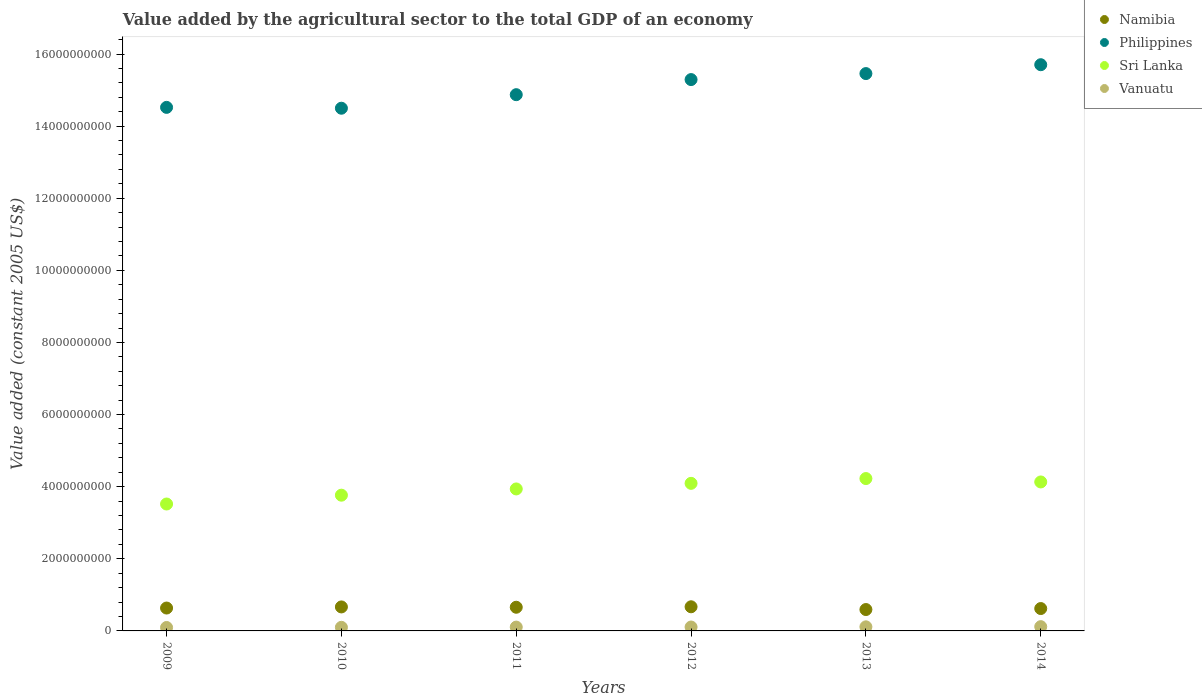How many different coloured dotlines are there?
Provide a succinct answer. 4. Is the number of dotlines equal to the number of legend labels?
Give a very brief answer. Yes. What is the value added by the agricultural sector in Philippines in 2009?
Offer a very short reply. 1.45e+1. Across all years, what is the maximum value added by the agricultural sector in Sri Lanka?
Your answer should be very brief. 4.23e+09. Across all years, what is the minimum value added by the agricultural sector in Philippines?
Make the answer very short. 1.45e+1. In which year was the value added by the agricultural sector in Sri Lanka maximum?
Provide a succinct answer. 2013. What is the total value added by the agricultural sector in Namibia in the graph?
Your answer should be compact. 3.84e+09. What is the difference between the value added by the agricultural sector in Philippines in 2012 and that in 2013?
Offer a terse response. -1.66e+08. What is the difference between the value added by the agricultural sector in Vanuatu in 2014 and the value added by the agricultural sector in Philippines in 2010?
Your answer should be very brief. -1.44e+1. What is the average value added by the agricultural sector in Sri Lanka per year?
Your response must be concise. 3.95e+09. In the year 2012, what is the difference between the value added by the agricultural sector in Namibia and value added by the agricultural sector in Sri Lanka?
Your response must be concise. -3.42e+09. In how many years, is the value added by the agricultural sector in Sri Lanka greater than 9200000000 US$?
Make the answer very short. 0. What is the ratio of the value added by the agricultural sector in Vanuatu in 2009 to that in 2010?
Give a very brief answer. 0.95. What is the difference between the highest and the second highest value added by the agricultural sector in Sri Lanka?
Provide a succinct answer. 9.42e+07. What is the difference between the highest and the lowest value added by the agricultural sector in Namibia?
Your answer should be compact. 7.63e+07. Is it the case that in every year, the sum of the value added by the agricultural sector in Vanuatu and value added by the agricultural sector in Namibia  is greater than the value added by the agricultural sector in Sri Lanka?
Provide a short and direct response. No. Is the value added by the agricultural sector in Namibia strictly less than the value added by the agricultural sector in Sri Lanka over the years?
Provide a short and direct response. Yes. Are the values on the major ticks of Y-axis written in scientific E-notation?
Provide a short and direct response. No. Does the graph contain any zero values?
Offer a very short reply. No. Where does the legend appear in the graph?
Keep it short and to the point. Top right. How many legend labels are there?
Provide a succinct answer. 4. What is the title of the graph?
Your answer should be compact. Value added by the agricultural sector to the total GDP of an economy. Does "Congo (Democratic)" appear as one of the legend labels in the graph?
Ensure brevity in your answer.  No. What is the label or title of the X-axis?
Your answer should be very brief. Years. What is the label or title of the Y-axis?
Provide a short and direct response. Value added (constant 2005 US$). What is the Value added (constant 2005 US$) of Namibia in 2009?
Provide a short and direct response. 6.35e+08. What is the Value added (constant 2005 US$) of Philippines in 2009?
Provide a succinct answer. 1.45e+1. What is the Value added (constant 2005 US$) of Sri Lanka in 2009?
Offer a terse response. 3.52e+09. What is the Value added (constant 2005 US$) of Vanuatu in 2009?
Your response must be concise. 9.54e+07. What is the Value added (constant 2005 US$) in Namibia in 2010?
Keep it short and to the point. 6.65e+08. What is the Value added (constant 2005 US$) of Philippines in 2010?
Keep it short and to the point. 1.45e+1. What is the Value added (constant 2005 US$) in Sri Lanka in 2010?
Give a very brief answer. 3.76e+09. What is the Value added (constant 2005 US$) in Vanuatu in 2010?
Your answer should be very brief. 1.00e+08. What is the Value added (constant 2005 US$) of Namibia in 2011?
Give a very brief answer. 6.57e+08. What is the Value added (constant 2005 US$) in Philippines in 2011?
Your response must be concise. 1.49e+1. What is the Value added (constant 2005 US$) of Sri Lanka in 2011?
Your answer should be very brief. 3.94e+09. What is the Value added (constant 2005 US$) in Vanuatu in 2011?
Your response must be concise. 1.06e+08. What is the Value added (constant 2005 US$) of Namibia in 2012?
Your response must be concise. 6.69e+08. What is the Value added (constant 2005 US$) of Philippines in 2012?
Provide a succinct answer. 1.53e+1. What is the Value added (constant 2005 US$) in Sri Lanka in 2012?
Offer a terse response. 4.09e+09. What is the Value added (constant 2005 US$) of Vanuatu in 2012?
Your answer should be very brief. 1.08e+08. What is the Value added (constant 2005 US$) of Namibia in 2013?
Give a very brief answer. 5.93e+08. What is the Value added (constant 2005 US$) of Philippines in 2013?
Your response must be concise. 1.55e+1. What is the Value added (constant 2005 US$) of Sri Lanka in 2013?
Keep it short and to the point. 4.23e+09. What is the Value added (constant 2005 US$) of Vanuatu in 2013?
Your response must be concise. 1.14e+08. What is the Value added (constant 2005 US$) of Namibia in 2014?
Ensure brevity in your answer.  6.21e+08. What is the Value added (constant 2005 US$) in Philippines in 2014?
Your response must be concise. 1.57e+1. What is the Value added (constant 2005 US$) of Sri Lanka in 2014?
Ensure brevity in your answer.  4.13e+09. What is the Value added (constant 2005 US$) of Vanuatu in 2014?
Your answer should be very brief. 1.18e+08. Across all years, what is the maximum Value added (constant 2005 US$) of Namibia?
Your answer should be very brief. 6.69e+08. Across all years, what is the maximum Value added (constant 2005 US$) in Philippines?
Your response must be concise. 1.57e+1. Across all years, what is the maximum Value added (constant 2005 US$) in Sri Lanka?
Offer a terse response. 4.23e+09. Across all years, what is the maximum Value added (constant 2005 US$) in Vanuatu?
Offer a very short reply. 1.18e+08. Across all years, what is the minimum Value added (constant 2005 US$) in Namibia?
Provide a short and direct response. 5.93e+08. Across all years, what is the minimum Value added (constant 2005 US$) in Philippines?
Your answer should be very brief. 1.45e+1. Across all years, what is the minimum Value added (constant 2005 US$) in Sri Lanka?
Provide a succinct answer. 3.52e+09. Across all years, what is the minimum Value added (constant 2005 US$) in Vanuatu?
Offer a very short reply. 9.54e+07. What is the total Value added (constant 2005 US$) in Namibia in the graph?
Offer a terse response. 3.84e+09. What is the total Value added (constant 2005 US$) in Philippines in the graph?
Offer a terse response. 9.03e+1. What is the total Value added (constant 2005 US$) of Sri Lanka in the graph?
Your answer should be very brief. 2.37e+1. What is the total Value added (constant 2005 US$) in Vanuatu in the graph?
Your answer should be very brief. 6.42e+08. What is the difference between the Value added (constant 2005 US$) of Namibia in 2009 and that in 2010?
Your answer should be compact. -3.08e+07. What is the difference between the Value added (constant 2005 US$) of Philippines in 2009 and that in 2010?
Ensure brevity in your answer.  2.36e+07. What is the difference between the Value added (constant 2005 US$) in Sri Lanka in 2009 and that in 2010?
Provide a short and direct response. -2.45e+08. What is the difference between the Value added (constant 2005 US$) in Vanuatu in 2009 and that in 2010?
Provide a succinct answer. -4.59e+06. What is the difference between the Value added (constant 2005 US$) of Namibia in 2009 and that in 2011?
Offer a very short reply. -2.20e+07. What is the difference between the Value added (constant 2005 US$) in Philippines in 2009 and that in 2011?
Provide a succinct answer. -3.52e+08. What is the difference between the Value added (constant 2005 US$) in Sri Lanka in 2009 and that in 2011?
Offer a terse response. -4.18e+08. What is the difference between the Value added (constant 2005 US$) of Vanuatu in 2009 and that in 2011?
Provide a succinct answer. -1.07e+07. What is the difference between the Value added (constant 2005 US$) of Namibia in 2009 and that in 2012?
Give a very brief answer. -3.49e+07. What is the difference between the Value added (constant 2005 US$) of Philippines in 2009 and that in 2012?
Your answer should be very brief. -7.71e+08. What is the difference between the Value added (constant 2005 US$) in Sri Lanka in 2009 and that in 2012?
Your response must be concise. -5.73e+08. What is the difference between the Value added (constant 2005 US$) in Vanuatu in 2009 and that in 2012?
Your answer should be compact. -1.30e+07. What is the difference between the Value added (constant 2005 US$) of Namibia in 2009 and that in 2013?
Your response must be concise. 4.15e+07. What is the difference between the Value added (constant 2005 US$) of Philippines in 2009 and that in 2013?
Your response must be concise. -9.37e+08. What is the difference between the Value added (constant 2005 US$) of Sri Lanka in 2009 and that in 2013?
Offer a terse response. -7.06e+08. What is the difference between the Value added (constant 2005 US$) in Vanuatu in 2009 and that in 2013?
Give a very brief answer. -1.82e+07. What is the difference between the Value added (constant 2005 US$) in Namibia in 2009 and that in 2014?
Your answer should be compact. 1.40e+07. What is the difference between the Value added (constant 2005 US$) in Philippines in 2009 and that in 2014?
Provide a succinct answer. -1.18e+09. What is the difference between the Value added (constant 2005 US$) of Sri Lanka in 2009 and that in 2014?
Make the answer very short. -6.12e+08. What is the difference between the Value added (constant 2005 US$) in Vanuatu in 2009 and that in 2014?
Offer a very short reply. -2.30e+07. What is the difference between the Value added (constant 2005 US$) in Namibia in 2010 and that in 2011?
Your answer should be very brief. 8.85e+06. What is the difference between the Value added (constant 2005 US$) of Philippines in 2010 and that in 2011?
Provide a succinct answer. -3.76e+08. What is the difference between the Value added (constant 2005 US$) in Sri Lanka in 2010 and that in 2011?
Offer a terse response. -1.73e+08. What is the difference between the Value added (constant 2005 US$) of Vanuatu in 2010 and that in 2011?
Provide a succinct answer. -6.06e+06. What is the difference between the Value added (constant 2005 US$) in Namibia in 2010 and that in 2012?
Provide a short and direct response. -4.06e+06. What is the difference between the Value added (constant 2005 US$) in Philippines in 2010 and that in 2012?
Your answer should be very brief. -7.94e+08. What is the difference between the Value added (constant 2005 US$) in Sri Lanka in 2010 and that in 2012?
Your response must be concise. -3.28e+08. What is the difference between the Value added (constant 2005 US$) in Vanuatu in 2010 and that in 2012?
Ensure brevity in your answer.  -8.42e+06. What is the difference between the Value added (constant 2005 US$) in Namibia in 2010 and that in 2013?
Provide a succinct answer. 7.23e+07. What is the difference between the Value added (constant 2005 US$) in Philippines in 2010 and that in 2013?
Your answer should be very brief. -9.61e+08. What is the difference between the Value added (constant 2005 US$) in Sri Lanka in 2010 and that in 2013?
Your answer should be compact. -4.61e+08. What is the difference between the Value added (constant 2005 US$) in Vanuatu in 2010 and that in 2013?
Offer a terse response. -1.36e+07. What is the difference between the Value added (constant 2005 US$) of Namibia in 2010 and that in 2014?
Ensure brevity in your answer.  4.48e+07. What is the difference between the Value added (constant 2005 US$) of Philippines in 2010 and that in 2014?
Offer a very short reply. -1.21e+09. What is the difference between the Value added (constant 2005 US$) in Sri Lanka in 2010 and that in 2014?
Provide a short and direct response. -3.67e+08. What is the difference between the Value added (constant 2005 US$) of Vanuatu in 2010 and that in 2014?
Make the answer very short. -1.84e+07. What is the difference between the Value added (constant 2005 US$) in Namibia in 2011 and that in 2012?
Make the answer very short. -1.29e+07. What is the difference between the Value added (constant 2005 US$) of Philippines in 2011 and that in 2012?
Your response must be concise. -4.19e+08. What is the difference between the Value added (constant 2005 US$) in Sri Lanka in 2011 and that in 2012?
Give a very brief answer. -1.55e+08. What is the difference between the Value added (constant 2005 US$) of Vanuatu in 2011 and that in 2012?
Give a very brief answer. -2.35e+06. What is the difference between the Value added (constant 2005 US$) of Namibia in 2011 and that in 2013?
Your answer should be compact. 6.34e+07. What is the difference between the Value added (constant 2005 US$) of Philippines in 2011 and that in 2013?
Provide a succinct answer. -5.85e+08. What is the difference between the Value added (constant 2005 US$) in Sri Lanka in 2011 and that in 2013?
Ensure brevity in your answer.  -2.88e+08. What is the difference between the Value added (constant 2005 US$) of Vanuatu in 2011 and that in 2013?
Provide a short and direct response. -7.53e+06. What is the difference between the Value added (constant 2005 US$) in Namibia in 2011 and that in 2014?
Provide a succinct answer. 3.60e+07. What is the difference between the Value added (constant 2005 US$) in Philippines in 2011 and that in 2014?
Offer a terse response. -8.31e+08. What is the difference between the Value added (constant 2005 US$) of Sri Lanka in 2011 and that in 2014?
Make the answer very short. -1.94e+08. What is the difference between the Value added (constant 2005 US$) in Vanuatu in 2011 and that in 2014?
Ensure brevity in your answer.  -1.23e+07. What is the difference between the Value added (constant 2005 US$) of Namibia in 2012 and that in 2013?
Your answer should be compact. 7.63e+07. What is the difference between the Value added (constant 2005 US$) in Philippines in 2012 and that in 2013?
Make the answer very short. -1.66e+08. What is the difference between the Value added (constant 2005 US$) in Sri Lanka in 2012 and that in 2013?
Make the answer very short. -1.33e+08. What is the difference between the Value added (constant 2005 US$) in Vanuatu in 2012 and that in 2013?
Your response must be concise. -5.18e+06. What is the difference between the Value added (constant 2005 US$) in Namibia in 2012 and that in 2014?
Make the answer very short. 4.89e+07. What is the difference between the Value added (constant 2005 US$) in Philippines in 2012 and that in 2014?
Offer a terse response. -4.12e+08. What is the difference between the Value added (constant 2005 US$) in Sri Lanka in 2012 and that in 2014?
Give a very brief answer. -3.87e+07. What is the difference between the Value added (constant 2005 US$) in Vanuatu in 2012 and that in 2014?
Provide a succinct answer. -9.97e+06. What is the difference between the Value added (constant 2005 US$) in Namibia in 2013 and that in 2014?
Offer a terse response. -2.74e+07. What is the difference between the Value added (constant 2005 US$) of Philippines in 2013 and that in 2014?
Provide a succinct answer. -2.46e+08. What is the difference between the Value added (constant 2005 US$) in Sri Lanka in 2013 and that in 2014?
Make the answer very short. 9.42e+07. What is the difference between the Value added (constant 2005 US$) in Vanuatu in 2013 and that in 2014?
Offer a terse response. -4.79e+06. What is the difference between the Value added (constant 2005 US$) in Namibia in 2009 and the Value added (constant 2005 US$) in Philippines in 2010?
Your answer should be very brief. -1.39e+1. What is the difference between the Value added (constant 2005 US$) of Namibia in 2009 and the Value added (constant 2005 US$) of Sri Lanka in 2010?
Keep it short and to the point. -3.13e+09. What is the difference between the Value added (constant 2005 US$) in Namibia in 2009 and the Value added (constant 2005 US$) in Vanuatu in 2010?
Offer a terse response. 5.35e+08. What is the difference between the Value added (constant 2005 US$) of Philippines in 2009 and the Value added (constant 2005 US$) of Sri Lanka in 2010?
Your response must be concise. 1.08e+1. What is the difference between the Value added (constant 2005 US$) of Philippines in 2009 and the Value added (constant 2005 US$) of Vanuatu in 2010?
Provide a succinct answer. 1.44e+1. What is the difference between the Value added (constant 2005 US$) in Sri Lanka in 2009 and the Value added (constant 2005 US$) in Vanuatu in 2010?
Give a very brief answer. 3.42e+09. What is the difference between the Value added (constant 2005 US$) in Namibia in 2009 and the Value added (constant 2005 US$) in Philippines in 2011?
Provide a succinct answer. -1.42e+1. What is the difference between the Value added (constant 2005 US$) in Namibia in 2009 and the Value added (constant 2005 US$) in Sri Lanka in 2011?
Keep it short and to the point. -3.30e+09. What is the difference between the Value added (constant 2005 US$) in Namibia in 2009 and the Value added (constant 2005 US$) in Vanuatu in 2011?
Keep it short and to the point. 5.29e+08. What is the difference between the Value added (constant 2005 US$) of Philippines in 2009 and the Value added (constant 2005 US$) of Sri Lanka in 2011?
Ensure brevity in your answer.  1.06e+1. What is the difference between the Value added (constant 2005 US$) in Philippines in 2009 and the Value added (constant 2005 US$) in Vanuatu in 2011?
Provide a succinct answer. 1.44e+1. What is the difference between the Value added (constant 2005 US$) in Sri Lanka in 2009 and the Value added (constant 2005 US$) in Vanuatu in 2011?
Your answer should be very brief. 3.41e+09. What is the difference between the Value added (constant 2005 US$) of Namibia in 2009 and the Value added (constant 2005 US$) of Philippines in 2012?
Provide a short and direct response. -1.47e+1. What is the difference between the Value added (constant 2005 US$) of Namibia in 2009 and the Value added (constant 2005 US$) of Sri Lanka in 2012?
Give a very brief answer. -3.46e+09. What is the difference between the Value added (constant 2005 US$) of Namibia in 2009 and the Value added (constant 2005 US$) of Vanuatu in 2012?
Provide a short and direct response. 5.26e+08. What is the difference between the Value added (constant 2005 US$) of Philippines in 2009 and the Value added (constant 2005 US$) of Sri Lanka in 2012?
Ensure brevity in your answer.  1.04e+1. What is the difference between the Value added (constant 2005 US$) of Philippines in 2009 and the Value added (constant 2005 US$) of Vanuatu in 2012?
Your answer should be very brief. 1.44e+1. What is the difference between the Value added (constant 2005 US$) in Sri Lanka in 2009 and the Value added (constant 2005 US$) in Vanuatu in 2012?
Give a very brief answer. 3.41e+09. What is the difference between the Value added (constant 2005 US$) of Namibia in 2009 and the Value added (constant 2005 US$) of Philippines in 2013?
Give a very brief answer. -1.48e+1. What is the difference between the Value added (constant 2005 US$) in Namibia in 2009 and the Value added (constant 2005 US$) in Sri Lanka in 2013?
Ensure brevity in your answer.  -3.59e+09. What is the difference between the Value added (constant 2005 US$) in Namibia in 2009 and the Value added (constant 2005 US$) in Vanuatu in 2013?
Your answer should be very brief. 5.21e+08. What is the difference between the Value added (constant 2005 US$) in Philippines in 2009 and the Value added (constant 2005 US$) in Sri Lanka in 2013?
Offer a terse response. 1.03e+1. What is the difference between the Value added (constant 2005 US$) in Philippines in 2009 and the Value added (constant 2005 US$) in Vanuatu in 2013?
Give a very brief answer. 1.44e+1. What is the difference between the Value added (constant 2005 US$) of Sri Lanka in 2009 and the Value added (constant 2005 US$) of Vanuatu in 2013?
Offer a terse response. 3.41e+09. What is the difference between the Value added (constant 2005 US$) of Namibia in 2009 and the Value added (constant 2005 US$) of Philippines in 2014?
Your answer should be very brief. -1.51e+1. What is the difference between the Value added (constant 2005 US$) of Namibia in 2009 and the Value added (constant 2005 US$) of Sri Lanka in 2014?
Offer a terse response. -3.50e+09. What is the difference between the Value added (constant 2005 US$) of Namibia in 2009 and the Value added (constant 2005 US$) of Vanuatu in 2014?
Your answer should be very brief. 5.16e+08. What is the difference between the Value added (constant 2005 US$) in Philippines in 2009 and the Value added (constant 2005 US$) in Sri Lanka in 2014?
Your answer should be compact. 1.04e+1. What is the difference between the Value added (constant 2005 US$) in Philippines in 2009 and the Value added (constant 2005 US$) in Vanuatu in 2014?
Make the answer very short. 1.44e+1. What is the difference between the Value added (constant 2005 US$) in Sri Lanka in 2009 and the Value added (constant 2005 US$) in Vanuatu in 2014?
Offer a terse response. 3.40e+09. What is the difference between the Value added (constant 2005 US$) in Namibia in 2010 and the Value added (constant 2005 US$) in Philippines in 2011?
Your answer should be compact. -1.42e+1. What is the difference between the Value added (constant 2005 US$) in Namibia in 2010 and the Value added (constant 2005 US$) in Sri Lanka in 2011?
Offer a terse response. -3.27e+09. What is the difference between the Value added (constant 2005 US$) in Namibia in 2010 and the Value added (constant 2005 US$) in Vanuatu in 2011?
Your answer should be compact. 5.59e+08. What is the difference between the Value added (constant 2005 US$) of Philippines in 2010 and the Value added (constant 2005 US$) of Sri Lanka in 2011?
Your response must be concise. 1.06e+1. What is the difference between the Value added (constant 2005 US$) in Philippines in 2010 and the Value added (constant 2005 US$) in Vanuatu in 2011?
Give a very brief answer. 1.44e+1. What is the difference between the Value added (constant 2005 US$) in Sri Lanka in 2010 and the Value added (constant 2005 US$) in Vanuatu in 2011?
Your response must be concise. 3.66e+09. What is the difference between the Value added (constant 2005 US$) in Namibia in 2010 and the Value added (constant 2005 US$) in Philippines in 2012?
Offer a terse response. -1.46e+1. What is the difference between the Value added (constant 2005 US$) of Namibia in 2010 and the Value added (constant 2005 US$) of Sri Lanka in 2012?
Your response must be concise. -3.43e+09. What is the difference between the Value added (constant 2005 US$) of Namibia in 2010 and the Value added (constant 2005 US$) of Vanuatu in 2012?
Your response must be concise. 5.57e+08. What is the difference between the Value added (constant 2005 US$) of Philippines in 2010 and the Value added (constant 2005 US$) of Sri Lanka in 2012?
Your answer should be very brief. 1.04e+1. What is the difference between the Value added (constant 2005 US$) of Philippines in 2010 and the Value added (constant 2005 US$) of Vanuatu in 2012?
Provide a short and direct response. 1.44e+1. What is the difference between the Value added (constant 2005 US$) of Sri Lanka in 2010 and the Value added (constant 2005 US$) of Vanuatu in 2012?
Provide a succinct answer. 3.66e+09. What is the difference between the Value added (constant 2005 US$) in Namibia in 2010 and the Value added (constant 2005 US$) in Philippines in 2013?
Your response must be concise. -1.48e+1. What is the difference between the Value added (constant 2005 US$) of Namibia in 2010 and the Value added (constant 2005 US$) of Sri Lanka in 2013?
Your response must be concise. -3.56e+09. What is the difference between the Value added (constant 2005 US$) in Namibia in 2010 and the Value added (constant 2005 US$) in Vanuatu in 2013?
Your answer should be compact. 5.52e+08. What is the difference between the Value added (constant 2005 US$) of Philippines in 2010 and the Value added (constant 2005 US$) of Sri Lanka in 2013?
Your answer should be compact. 1.03e+1. What is the difference between the Value added (constant 2005 US$) of Philippines in 2010 and the Value added (constant 2005 US$) of Vanuatu in 2013?
Provide a short and direct response. 1.44e+1. What is the difference between the Value added (constant 2005 US$) in Sri Lanka in 2010 and the Value added (constant 2005 US$) in Vanuatu in 2013?
Your answer should be very brief. 3.65e+09. What is the difference between the Value added (constant 2005 US$) in Namibia in 2010 and the Value added (constant 2005 US$) in Philippines in 2014?
Your answer should be compact. -1.50e+1. What is the difference between the Value added (constant 2005 US$) of Namibia in 2010 and the Value added (constant 2005 US$) of Sri Lanka in 2014?
Make the answer very short. -3.47e+09. What is the difference between the Value added (constant 2005 US$) of Namibia in 2010 and the Value added (constant 2005 US$) of Vanuatu in 2014?
Make the answer very short. 5.47e+08. What is the difference between the Value added (constant 2005 US$) in Philippines in 2010 and the Value added (constant 2005 US$) in Sri Lanka in 2014?
Offer a very short reply. 1.04e+1. What is the difference between the Value added (constant 2005 US$) of Philippines in 2010 and the Value added (constant 2005 US$) of Vanuatu in 2014?
Provide a short and direct response. 1.44e+1. What is the difference between the Value added (constant 2005 US$) of Sri Lanka in 2010 and the Value added (constant 2005 US$) of Vanuatu in 2014?
Ensure brevity in your answer.  3.65e+09. What is the difference between the Value added (constant 2005 US$) of Namibia in 2011 and the Value added (constant 2005 US$) of Philippines in 2012?
Offer a terse response. -1.46e+1. What is the difference between the Value added (constant 2005 US$) in Namibia in 2011 and the Value added (constant 2005 US$) in Sri Lanka in 2012?
Ensure brevity in your answer.  -3.44e+09. What is the difference between the Value added (constant 2005 US$) of Namibia in 2011 and the Value added (constant 2005 US$) of Vanuatu in 2012?
Make the answer very short. 5.48e+08. What is the difference between the Value added (constant 2005 US$) of Philippines in 2011 and the Value added (constant 2005 US$) of Sri Lanka in 2012?
Give a very brief answer. 1.08e+1. What is the difference between the Value added (constant 2005 US$) in Philippines in 2011 and the Value added (constant 2005 US$) in Vanuatu in 2012?
Your response must be concise. 1.48e+1. What is the difference between the Value added (constant 2005 US$) of Sri Lanka in 2011 and the Value added (constant 2005 US$) of Vanuatu in 2012?
Give a very brief answer. 3.83e+09. What is the difference between the Value added (constant 2005 US$) in Namibia in 2011 and the Value added (constant 2005 US$) in Philippines in 2013?
Ensure brevity in your answer.  -1.48e+1. What is the difference between the Value added (constant 2005 US$) in Namibia in 2011 and the Value added (constant 2005 US$) in Sri Lanka in 2013?
Your answer should be very brief. -3.57e+09. What is the difference between the Value added (constant 2005 US$) of Namibia in 2011 and the Value added (constant 2005 US$) of Vanuatu in 2013?
Your answer should be compact. 5.43e+08. What is the difference between the Value added (constant 2005 US$) in Philippines in 2011 and the Value added (constant 2005 US$) in Sri Lanka in 2013?
Your response must be concise. 1.06e+1. What is the difference between the Value added (constant 2005 US$) in Philippines in 2011 and the Value added (constant 2005 US$) in Vanuatu in 2013?
Offer a terse response. 1.48e+1. What is the difference between the Value added (constant 2005 US$) of Sri Lanka in 2011 and the Value added (constant 2005 US$) of Vanuatu in 2013?
Keep it short and to the point. 3.82e+09. What is the difference between the Value added (constant 2005 US$) of Namibia in 2011 and the Value added (constant 2005 US$) of Philippines in 2014?
Offer a terse response. -1.50e+1. What is the difference between the Value added (constant 2005 US$) in Namibia in 2011 and the Value added (constant 2005 US$) in Sri Lanka in 2014?
Offer a very short reply. -3.47e+09. What is the difference between the Value added (constant 2005 US$) in Namibia in 2011 and the Value added (constant 2005 US$) in Vanuatu in 2014?
Make the answer very short. 5.38e+08. What is the difference between the Value added (constant 2005 US$) of Philippines in 2011 and the Value added (constant 2005 US$) of Sri Lanka in 2014?
Make the answer very short. 1.07e+1. What is the difference between the Value added (constant 2005 US$) in Philippines in 2011 and the Value added (constant 2005 US$) in Vanuatu in 2014?
Ensure brevity in your answer.  1.48e+1. What is the difference between the Value added (constant 2005 US$) of Sri Lanka in 2011 and the Value added (constant 2005 US$) of Vanuatu in 2014?
Provide a short and direct response. 3.82e+09. What is the difference between the Value added (constant 2005 US$) in Namibia in 2012 and the Value added (constant 2005 US$) in Philippines in 2013?
Give a very brief answer. -1.48e+1. What is the difference between the Value added (constant 2005 US$) of Namibia in 2012 and the Value added (constant 2005 US$) of Sri Lanka in 2013?
Your response must be concise. -3.56e+09. What is the difference between the Value added (constant 2005 US$) in Namibia in 2012 and the Value added (constant 2005 US$) in Vanuatu in 2013?
Provide a short and direct response. 5.56e+08. What is the difference between the Value added (constant 2005 US$) in Philippines in 2012 and the Value added (constant 2005 US$) in Sri Lanka in 2013?
Keep it short and to the point. 1.11e+1. What is the difference between the Value added (constant 2005 US$) of Philippines in 2012 and the Value added (constant 2005 US$) of Vanuatu in 2013?
Your answer should be very brief. 1.52e+1. What is the difference between the Value added (constant 2005 US$) of Sri Lanka in 2012 and the Value added (constant 2005 US$) of Vanuatu in 2013?
Keep it short and to the point. 3.98e+09. What is the difference between the Value added (constant 2005 US$) of Namibia in 2012 and the Value added (constant 2005 US$) of Philippines in 2014?
Your answer should be very brief. -1.50e+1. What is the difference between the Value added (constant 2005 US$) of Namibia in 2012 and the Value added (constant 2005 US$) of Sri Lanka in 2014?
Make the answer very short. -3.46e+09. What is the difference between the Value added (constant 2005 US$) in Namibia in 2012 and the Value added (constant 2005 US$) in Vanuatu in 2014?
Provide a short and direct response. 5.51e+08. What is the difference between the Value added (constant 2005 US$) of Philippines in 2012 and the Value added (constant 2005 US$) of Sri Lanka in 2014?
Your response must be concise. 1.12e+1. What is the difference between the Value added (constant 2005 US$) of Philippines in 2012 and the Value added (constant 2005 US$) of Vanuatu in 2014?
Keep it short and to the point. 1.52e+1. What is the difference between the Value added (constant 2005 US$) in Sri Lanka in 2012 and the Value added (constant 2005 US$) in Vanuatu in 2014?
Keep it short and to the point. 3.97e+09. What is the difference between the Value added (constant 2005 US$) of Namibia in 2013 and the Value added (constant 2005 US$) of Philippines in 2014?
Your response must be concise. -1.51e+1. What is the difference between the Value added (constant 2005 US$) in Namibia in 2013 and the Value added (constant 2005 US$) in Sri Lanka in 2014?
Give a very brief answer. -3.54e+09. What is the difference between the Value added (constant 2005 US$) in Namibia in 2013 and the Value added (constant 2005 US$) in Vanuatu in 2014?
Provide a succinct answer. 4.75e+08. What is the difference between the Value added (constant 2005 US$) in Philippines in 2013 and the Value added (constant 2005 US$) in Sri Lanka in 2014?
Your response must be concise. 1.13e+1. What is the difference between the Value added (constant 2005 US$) of Philippines in 2013 and the Value added (constant 2005 US$) of Vanuatu in 2014?
Give a very brief answer. 1.53e+1. What is the difference between the Value added (constant 2005 US$) in Sri Lanka in 2013 and the Value added (constant 2005 US$) in Vanuatu in 2014?
Give a very brief answer. 4.11e+09. What is the average Value added (constant 2005 US$) in Namibia per year?
Make the answer very short. 6.40e+08. What is the average Value added (constant 2005 US$) of Philippines per year?
Ensure brevity in your answer.  1.51e+1. What is the average Value added (constant 2005 US$) of Sri Lanka per year?
Make the answer very short. 3.95e+09. What is the average Value added (constant 2005 US$) in Vanuatu per year?
Provide a short and direct response. 1.07e+08. In the year 2009, what is the difference between the Value added (constant 2005 US$) in Namibia and Value added (constant 2005 US$) in Philippines?
Give a very brief answer. -1.39e+1. In the year 2009, what is the difference between the Value added (constant 2005 US$) in Namibia and Value added (constant 2005 US$) in Sri Lanka?
Make the answer very short. -2.89e+09. In the year 2009, what is the difference between the Value added (constant 2005 US$) of Namibia and Value added (constant 2005 US$) of Vanuatu?
Offer a terse response. 5.39e+08. In the year 2009, what is the difference between the Value added (constant 2005 US$) in Philippines and Value added (constant 2005 US$) in Sri Lanka?
Your answer should be very brief. 1.10e+1. In the year 2009, what is the difference between the Value added (constant 2005 US$) in Philippines and Value added (constant 2005 US$) in Vanuatu?
Make the answer very short. 1.44e+1. In the year 2009, what is the difference between the Value added (constant 2005 US$) of Sri Lanka and Value added (constant 2005 US$) of Vanuatu?
Provide a succinct answer. 3.42e+09. In the year 2010, what is the difference between the Value added (constant 2005 US$) in Namibia and Value added (constant 2005 US$) in Philippines?
Make the answer very short. -1.38e+1. In the year 2010, what is the difference between the Value added (constant 2005 US$) in Namibia and Value added (constant 2005 US$) in Sri Lanka?
Your answer should be very brief. -3.10e+09. In the year 2010, what is the difference between the Value added (constant 2005 US$) in Namibia and Value added (constant 2005 US$) in Vanuatu?
Keep it short and to the point. 5.65e+08. In the year 2010, what is the difference between the Value added (constant 2005 US$) of Philippines and Value added (constant 2005 US$) of Sri Lanka?
Provide a short and direct response. 1.07e+1. In the year 2010, what is the difference between the Value added (constant 2005 US$) in Philippines and Value added (constant 2005 US$) in Vanuatu?
Provide a succinct answer. 1.44e+1. In the year 2010, what is the difference between the Value added (constant 2005 US$) of Sri Lanka and Value added (constant 2005 US$) of Vanuatu?
Provide a short and direct response. 3.66e+09. In the year 2011, what is the difference between the Value added (constant 2005 US$) of Namibia and Value added (constant 2005 US$) of Philippines?
Your answer should be compact. -1.42e+1. In the year 2011, what is the difference between the Value added (constant 2005 US$) in Namibia and Value added (constant 2005 US$) in Sri Lanka?
Make the answer very short. -3.28e+09. In the year 2011, what is the difference between the Value added (constant 2005 US$) of Namibia and Value added (constant 2005 US$) of Vanuatu?
Your answer should be very brief. 5.50e+08. In the year 2011, what is the difference between the Value added (constant 2005 US$) in Philippines and Value added (constant 2005 US$) in Sri Lanka?
Your response must be concise. 1.09e+1. In the year 2011, what is the difference between the Value added (constant 2005 US$) in Philippines and Value added (constant 2005 US$) in Vanuatu?
Give a very brief answer. 1.48e+1. In the year 2011, what is the difference between the Value added (constant 2005 US$) in Sri Lanka and Value added (constant 2005 US$) in Vanuatu?
Your response must be concise. 3.83e+09. In the year 2012, what is the difference between the Value added (constant 2005 US$) of Namibia and Value added (constant 2005 US$) of Philippines?
Your response must be concise. -1.46e+1. In the year 2012, what is the difference between the Value added (constant 2005 US$) of Namibia and Value added (constant 2005 US$) of Sri Lanka?
Keep it short and to the point. -3.42e+09. In the year 2012, what is the difference between the Value added (constant 2005 US$) of Namibia and Value added (constant 2005 US$) of Vanuatu?
Give a very brief answer. 5.61e+08. In the year 2012, what is the difference between the Value added (constant 2005 US$) in Philippines and Value added (constant 2005 US$) in Sri Lanka?
Your response must be concise. 1.12e+1. In the year 2012, what is the difference between the Value added (constant 2005 US$) of Philippines and Value added (constant 2005 US$) of Vanuatu?
Your answer should be compact. 1.52e+1. In the year 2012, what is the difference between the Value added (constant 2005 US$) in Sri Lanka and Value added (constant 2005 US$) in Vanuatu?
Your answer should be compact. 3.98e+09. In the year 2013, what is the difference between the Value added (constant 2005 US$) of Namibia and Value added (constant 2005 US$) of Philippines?
Your answer should be very brief. -1.49e+1. In the year 2013, what is the difference between the Value added (constant 2005 US$) of Namibia and Value added (constant 2005 US$) of Sri Lanka?
Provide a short and direct response. -3.63e+09. In the year 2013, what is the difference between the Value added (constant 2005 US$) in Namibia and Value added (constant 2005 US$) in Vanuatu?
Your response must be concise. 4.80e+08. In the year 2013, what is the difference between the Value added (constant 2005 US$) of Philippines and Value added (constant 2005 US$) of Sri Lanka?
Your response must be concise. 1.12e+1. In the year 2013, what is the difference between the Value added (constant 2005 US$) in Philippines and Value added (constant 2005 US$) in Vanuatu?
Your answer should be very brief. 1.53e+1. In the year 2013, what is the difference between the Value added (constant 2005 US$) of Sri Lanka and Value added (constant 2005 US$) of Vanuatu?
Make the answer very short. 4.11e+09. In the year 2014, what is the difference between the Value added (constant 2005 US$) in Namibia and Value added (constant 2005 US$) in Philippines?
Offer a very short reply. -1.51e+1. In the year 2014, what is the difference between the Value added (constant 2005 US$) in Namibia and Value added (constant 2005 US$) in Sri Lanka?
Offer a terse response. -3.51e+09. In the year 2014, what is the difference between the Value added (constant 2005 US$) of Namibia and Value added (constant 2005 US$) of Vanuatu?
Keep it short and to the point. 5.02e+08. In the year 2014, what is the difference between the Value added (constant 2005 US$) of Philippines and Value added (constant 2005 US$) of Sri Lanka?
Provide a short and direct response. 1.16e+1. In the year 2014, what is the difference between the Value added (constant 2005 US$) in Philippines and Value added (constant 2005 US$) in Vanuatu?
Ensure brevity in your answer.  1.56e+1. In the year 2014, what is the difference between the Value added (constant 2005 US$) in Sri Lanka and Value added (constant 2005 US$) in Vanuatu?
Give a very brief answer. 4.01e+09. What is the ratio of the Value added (constant 2005 US$) of Namibia in 2009 to that in 2010?
Your answer should be very brief. 0.95. What is the ratio of the Value added (constant 2005 US$) in Sri Lanka in 2009 to that in 2010?
Give a very brief answer. 0.94. What is the ratio of the Value added (constant 2005 US$) of Vanuatu in 2009 to that in 2010?
Offer a very short reply. 0.95. What is the ratio of the Value added (constant 2005 US$) in Namibia in 2009 to that in 2011?
Offer a terse response. 0.97. What is the ratio of the Value added (constant 2005 US$) in Philippines in 2009 to that in 2011?
Provide a short and direct response. 0.98. What is the ratio of the Value added (constant 2005 US$) of Sri Lanka in 2009 to that in 2011?
Your answer should be compact. 0.89. What is the ratio of the Value added (constant 2005 US$) of Vanuatu in 2009 to that in 2011?
Provide a succinct answer. 0.9. What is the ratio of the Value added (constant 2005 US$) of Namibia in 2009 to that in 2012?
Provide a short and direct response. 0.95. What is the ratio of the Value added (constant 2005 US$) of Philippines in 2009 to that in 2012?
Offer a very short reply. 0.95. What is the ratio of the Value added (constant 2005 US$) of Sri Lanka in 2009 to that in 2012?
Ensure brevity in your answer.  0.86. What is the ratio of the Value added (constant 2005 US$) in Vanuatu in 2009 to that in 2012?
Your response must be concise. 0.88. What is the ratio of the Value added (constant 2005 US$) in Namibia in 2009 to that in 2013?
Give a very brief answer. 1.07. What is the ratio of the Value added (constant 2005 US$) of Philippines in 2009 to that in 2013?
Give a very brief answer. 0.94. What is the ratio of the Value added (constant 2005 US$) in Sri Lanka in 2009 to that in 2013?
Offer a terse response. 0.83. What is the ratio of the Value added (constant 2005 US$) of Vanuatu in 2009 to that in 2013?
Provide a succinct answer. 0.84. What is the ratio of the Value added (constant 2005 US$) in Namibia in 2009 to that in 2014?
Your response must be concise. 1.02. What is the ratio of the Value added (constant 2005 US$) of Philippines in 2009 to that in 2014?
Your answer should be compact. 0.92. What is the ratio of the Value added (constant 2005 US$) in Sri Lanka in 2009 to that in 2014?
Your answer should be very brief. 0.85. What is the ratio of the Value added (constant 2005 US$) in Vanuatu in 2009 to that in 2014?
Your answer should be compact. 0.81. What is the ratio of the Value added (constant 2005 US$) of Namibia in 2010 to that in 2011?
Your response must be concise. 1.01. What is the ratio of the Value added (constant 2005 US$) of Philippines in 2010 to that in 2011?
Your response must be concise. 0.97. What is the ratio of the Value added (constant 2005 US$) in Sri Lanka in 2010 to that in 2011?
Your response must be concise. 0.96. What is the ratio of the Value added (constant 2005 US$) in Vanuatu in 2010 to that in 2011?
Offer a terse response. 0.94. What is the ratio of the Value added (constant 2005 US$) of Philippines in 2010 to that in 2012?
Make the answer very short. 0.95. What is the ratio of the Value added (constant 2005 US$) of Sri Lanka in 2010 to that in 2012?
Keep it short and to the point. 0.92. What is the ratio of the Value added (constant 2005 US$) of Vanuatu in 2010 to that in 2012?
Your answer should be very brief. 0.92. What is the ratio of the Value added (constant 2005 US$) in Namibia in 2010 to that in 2013?
Your answer should be compact. 1.12. What is the ratio of the Value added (constant 2005 US$) in Philippines in 2010 to that in 2013?
Make the answer very short. 0.94. What is the ratio of the Value added (constant 2005 US$) in Sri Lanka in 2010 to that in 2013?
Make the answer very short. 0.89. What is the ratio of the Value added (constant 2005 US$) of Vanuatu in 2010 to that in 2013?
Offer a terse response. 0.88. What is the ratio of the Value added (constant 2005 US$) in Namibia in 2010 to that in 2014?
Your answer should be very brief. 1.07. What is the ratio of the Value added (constant 2005 US$) in Philippines in 2010 to that in 2014?
Your response must be concise. 0.92. What is the ratio of the Value added (constant 2005 US$) in Sri Lanka in 2010 to that in 2014?
Provide a short and direct response. 0.91. What is the ratio of the Value added (constant 2005 US$) in Vanuatu in 2010 to that in 2014?
Offer a terse response. 0.84. What is the ratio of the Value added (constant 2005 US$) of Namibia in 2011 to that in 2012?
Your answer should be very brief. 0.98. What is the ratio of the Value added (constant 2005 US$) in Philippines in 2011 to that in 2012?
Ensure brevity in your answer.  0.97. What is the ratio of the Value added (constant 2005 US$) in Sri Lanka in 2011 to that in 2012?
Give a very brief answer. 0.96. What is the ratio of the Value added (constant 2005 US$) of Vanuatu in 2011 to that in 2012?
Offer a very short reply. 0.98. What is the ratio of the Value added (constant 2005 US$) in Namibia in 2011 to that in 2013?
Make the answer very short. 1.11. What is the ratio of the Value added (constant 2005 US$) of Philippines in 2011 to that in 2013?
Offer a very short reply. 0.96. What is the ratio of the Value added (constant 2005 US$) of Sri Lanka in 2011 to that in 2013?
Your response must be concise. 0.93. What is the ratio of the Value added (constant 2005 US$) in Vanuatu in 2011 to that in 2013?
Your response must be concise. 0.93. What is the ratio of the Value added (constant 2005 US$) in Namibia in 2011 to that in 2014?
Offer a very short reply. 1.06. What is the ratio of the Value added (constant 2005 US$) in Philippines in 2011 to that in 2014?
Your response must be concise. 0.95. What is the ratio of the Value added (constant 2005 US$) in Sri Lanka in 2011 to that in 2014?
Your response must be concise. 0.95. What is the ratio of the Value added (constant 2005 US$) of Vanuatu in 2011 to that in 2014?
Provide a succinct answer. 0.9. What is the ratio of the Value added (constant 2005 US$) of Namibia in 2012 to that in 2013?
Your response must be concise. 1.13. What is the ratio of the Value added (constant 2005 US$) of Philippines in 2012 to that in 2013?
Offer a very short reply. 0.99. What is the ratio of the Value added (constant 2005 US$) in Sri Lanka in 2012 to that in 2013?
Keep it short and to the point. 0.97. What is the ratio of the Value added (constant 2005 US$) of Vanuatu in 2012 to that in 2013?
Give a very brief answer. 0.95. What is the ratio of the Value added (constant 2005 US$) of Namibia in 2012 to that in 2014?
Provide a short and direct response. 1.08. What is the ratio of the Value added (constant 2005 US$) of Philippines in 2012 to that in 2014?
Provide a short and direct response. 0.97. What is the ratio of the Value added (constant 2005 US$) in Sri Lanka in 2012 to that in 2014?
Offer a terse response. 0.99. What is the ratio of the Value added (constant 2005 US$) of Vanuatu in 2012 to that in 2014?
Offer a very short reply. 0.92. What is the ratio of the Value added (constant 2005 US$) of Namibia in 2013 to that in 2014?
Provide a short and direct response. 0.96. What is the ratio of the Value added (constant 2005 US$) of Philippines in 2013 to that in 2014?
Provide a succinct answer. 0.98. What is the ratio of the Value added (constant 2005 US$) in Sri Lanka in 2013 to that in 2014?
Your answer should be very brief. 1.02. What is the ratio of the Value added (constant 2005 US$) of Vanuatu in 2013 to that in 2014?
Make the answer very short. 0.96. What is the difference between the highest and the second highest Value added (constant 2005 US$) of Namibia?
Give a very brief answer. 4.06e+06. What is the difference between the highest and the second highest Value added (constant 2005 US$) of Philippines?
Provide a succinct answer. 2.46e+08. What is the difference between the highest and the second highest Value added (constant 2005 US$) in Sri Lanka?
Provide a succinct answer. 9.42e+07. What is the difference between the highest and the second highest Value added (constant 2005 US$) of Vanuatu?
Give a very brief answer. 4.79e+06. What is the difference between the highest and the lowest Value added (constant 2005 US$) in Namibia?
Your answer should be compact. 7.63e+07. What is the difference between the highest and the lowest Value added (constant 2005 US$) of Philippines?
Give a very brief answer. 1.21e+09. What is the difference between the highest and the lowest Value added (constant 2005 US$) in Sri Lanka?
Keep it short and to the point. 7.06e+08. What is the difference between the highest and the lowest Value added (constant 2005 US$) of Vanuatu?
Provide a succinct answer. 2.30e+07. 